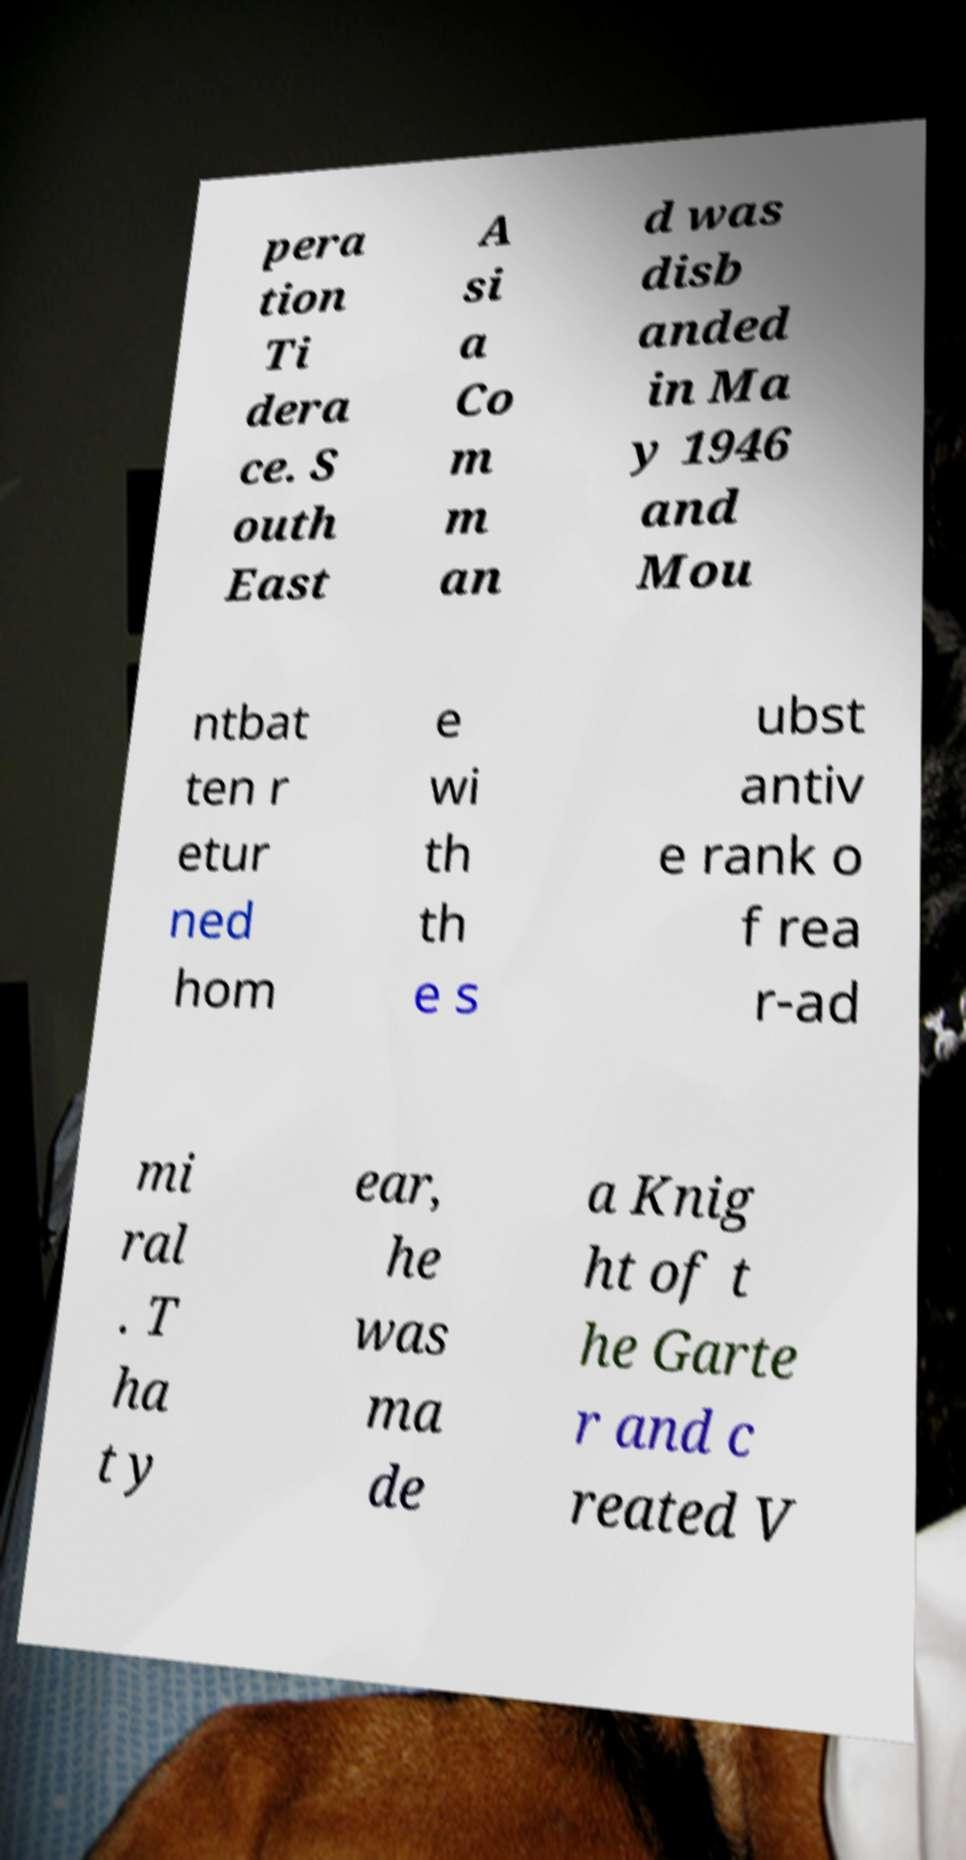Please identify and transcribe the text found in this image. pera tion Ti dera ce. S outh East A si a Co m m an d was disb anded in Ma y 1946 and Mou ntbat ten r etur ned hom e wi th th e s ubst antiv e rank o f rea r-ad mi ral . T ha t y ear, he was ma de a Knig ht of t he Garte r and c reated V 